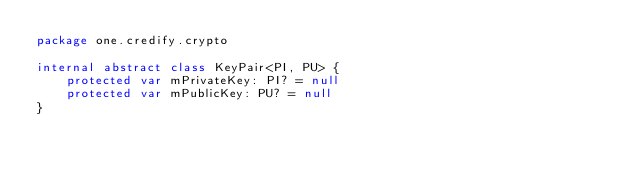Convert code to text. <code><loc_0><loc_0><loc_500><loc_500><_Kotlin_>package one.credify.crypto

internal abstract class KeyPair<PI, PU> {
    protected var mPrivateKey: PI? = null
    protected var mPublicKey: PU? = null
}</code> 